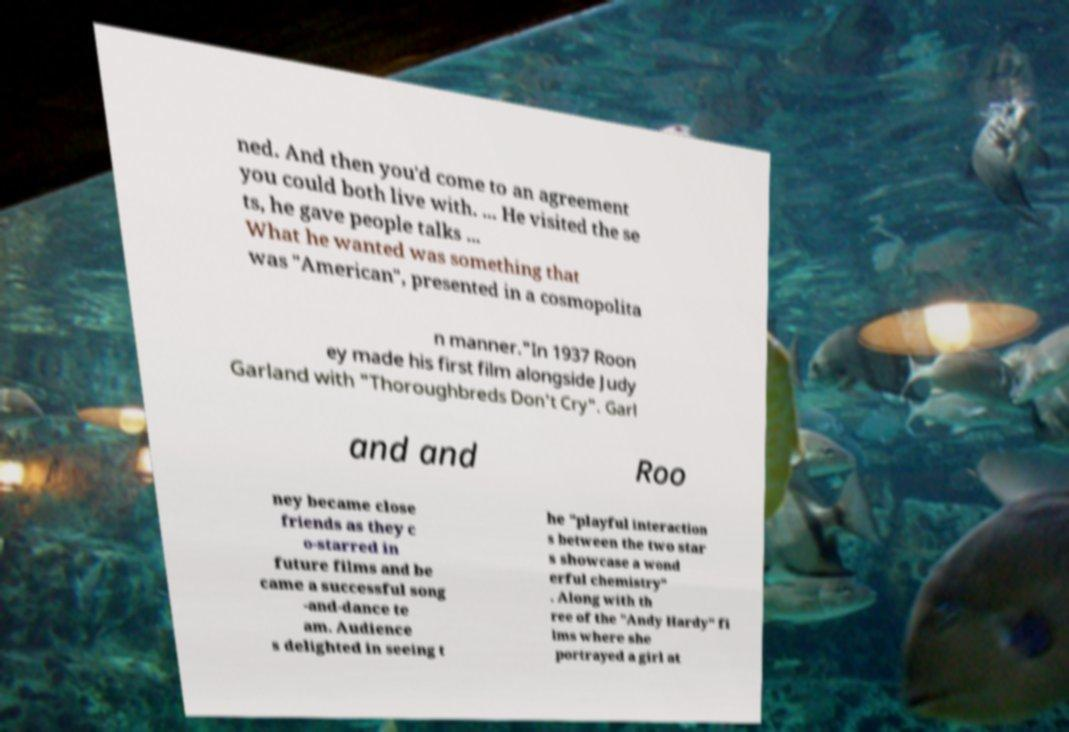Please read and relay the text visible in this image. What does it say? ned. And then you'd come to an agreement you could both live with. ... He visited the se ts, he gave people talks ... What he wanted was something that was "American", presented in a cosmopolita n manner."In 1937 Roon ey made his first film alongside Judy Garland with "Thoroughbreds Don't Cry". Garl and and Roo ney became close friends as they c o-starred in future films and be came a successful song -and-dance te am. Audience s delighted in seeing t he "playful interaction s between the two star s showcase a wond erful chemistry" . Along with th ree of the "Andy Hardy" fi lms where she portrayed a girl at 